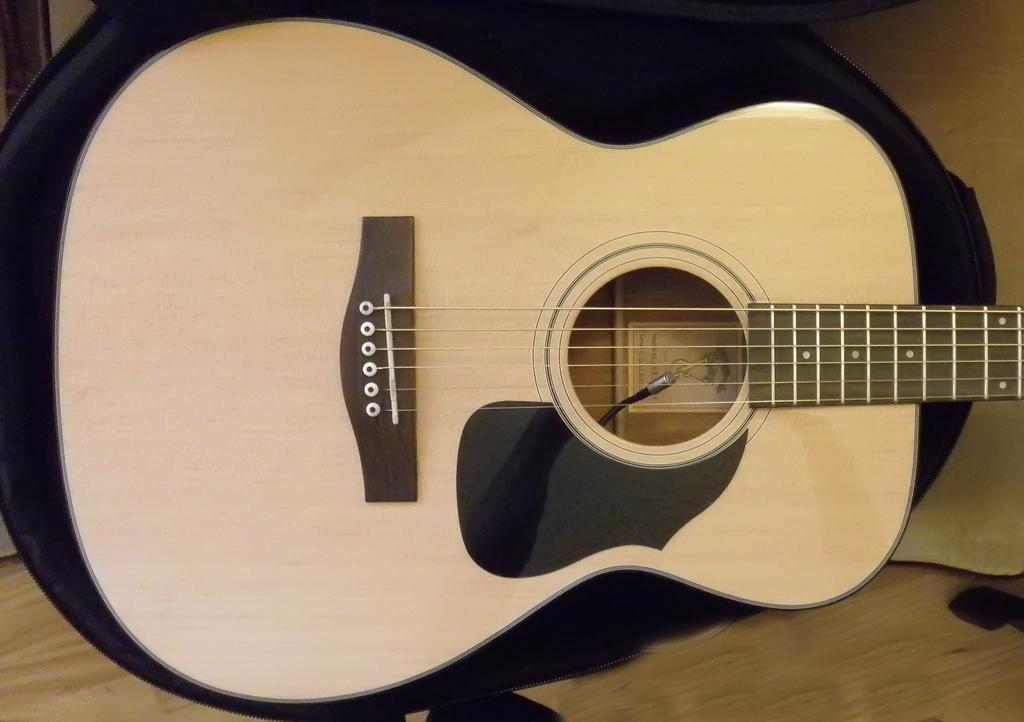In one or two sentences, can you explain what this image depicts? In this image there is one guitar, and on the bottom there is a wooden floor. 